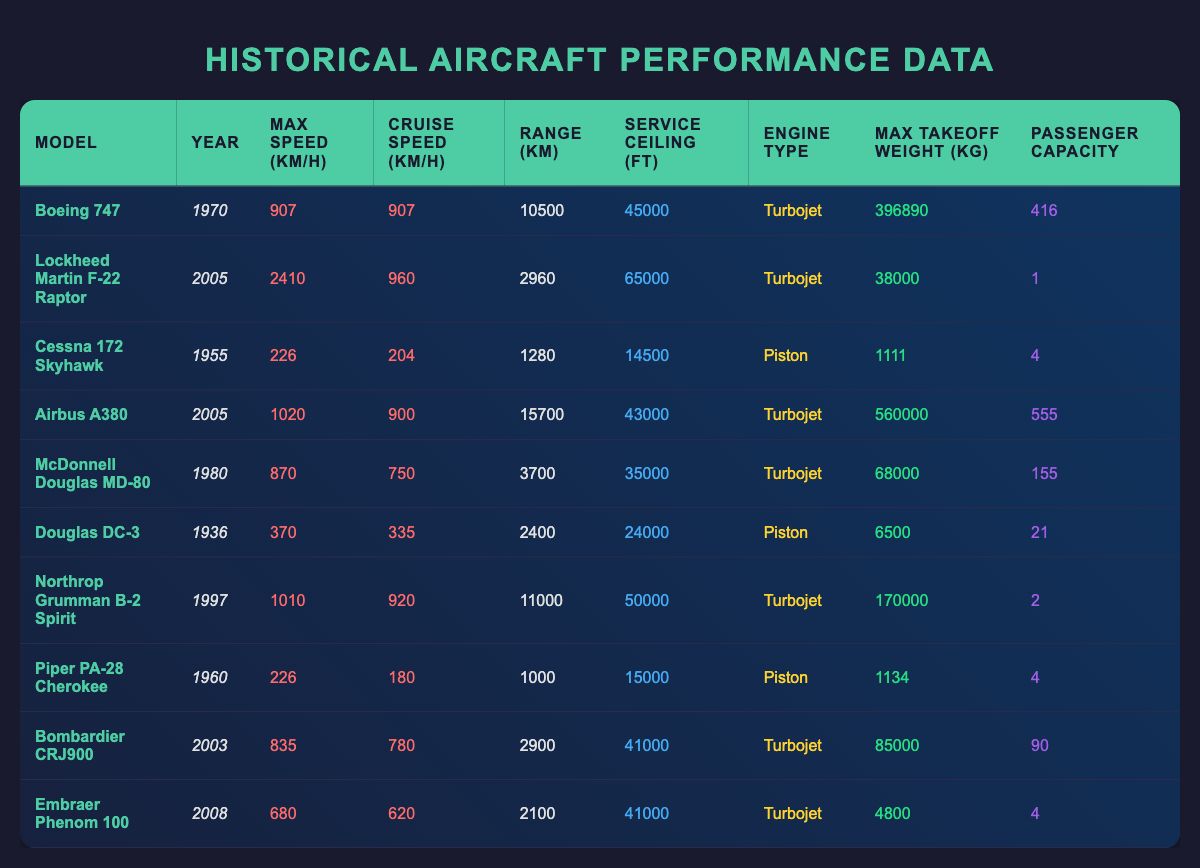What is the maximum speed of the Boeing 747? The table indicates that the maximum speed for the Boeing 747 is listed under the "Max Speed (km/h)" column, which shows a value of 907.
Answer: 907 Which aircraft has the largest passenger capacity? By examining the "Passenger Capacity" column, the Airbus A380 has the highest value listed, which is 555.
Answer: 555 Is the Lockheed Martin F-22 Raptor introduced before the Airbus A380? The year introduced for the F-22 Raptor is 2005, while the Airbus A380 was also introduced in 2005, meaning they were introduced in the same year; therefore, the answer is false.
Answer: No What is the range of the McDonnell Douglas MD-80 compared to the Douglas DC-3? Looking at the "Range (km)" column, the MD-80 has a range of 3700, while the DC-3 has a range of 2400. To determine the difference, we calculate 3700 - 2400 = 1300; thus, MD-80 has a greater range by 1300 km.
Answer: 1300 km What is the average maximum takeoff weight of all turbojet aircraft listed in the table? We first identify turbojet aircraft: Boeing 747, F-22 Raptor, Airbus A380, MD-80, B-2 Spirit, Bombardier CRJ900, and Embraer Phenom 100, yielding their weights of 396890, 38000, 560000, 68000, 170000, 85000, and 4800 respectively. Summing these gives 396890 + 38000 + 560000 + 68000 + 170000 + 85000 + 4800 = 1296688 kg. There are 7 turbojet aircraft, so the average weight is 1296688 / 7 = 185238.29 kg (rounded to the nearest whole number is 185238).
Answer: 185238 kg Does the Cessna 172 Skyhawk have a higher service ceiling than the Piper PA-28 Cherokee? The Cessna 172 has a service ceiling of 14500 feet compared to the Piper PA-28 Cherokee's service ceiling of 15000 feet; since 15000 is greater than 14500, this means the statement is false.
Answer: No 